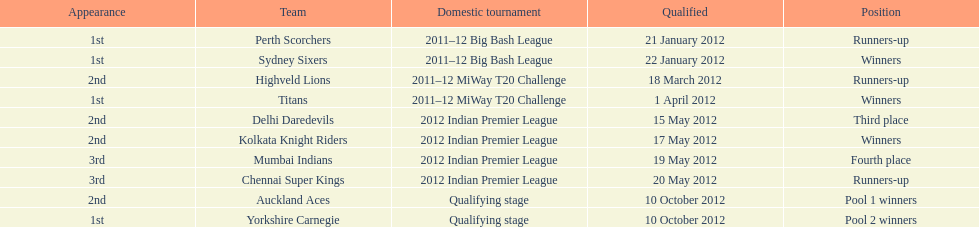Which game came in first in the 2012 indian premier league? Kolkata Knight Riders. 